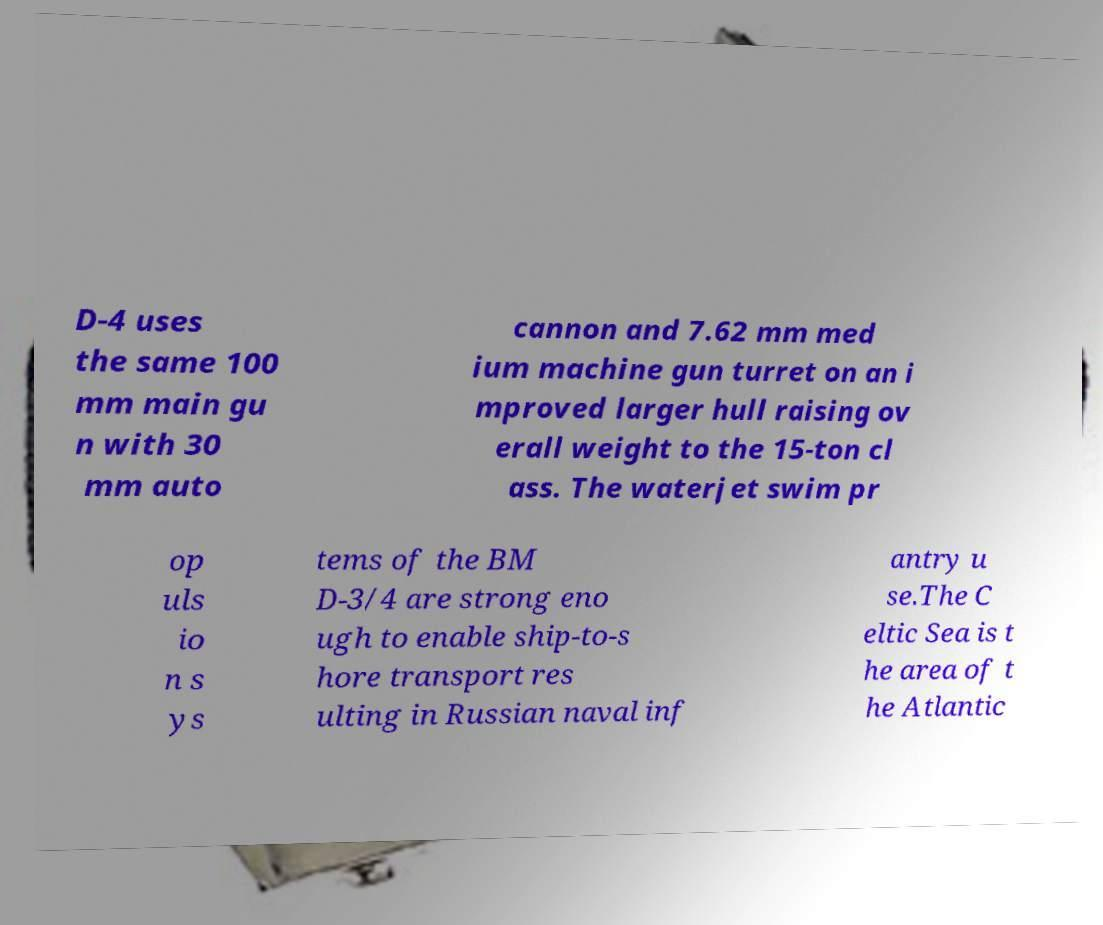What messages or text are displayed in this image? I need them in a readable, typed format. D-4 uses the same 100 mm main gu n with 30 mm auto cannon and 7.62 mm med ium machine gun turret on an i mproved larger hull raising ov erall weight to the 15-ton cl ass. The waterjet swim pr op uls io n s ys tems of the BM D-3/4 are strong eno ugh to enable ship-to-s hore transport res ulting in Russian naval inf antry u se.The C eltic Sea is t he area of t he Atlantic 